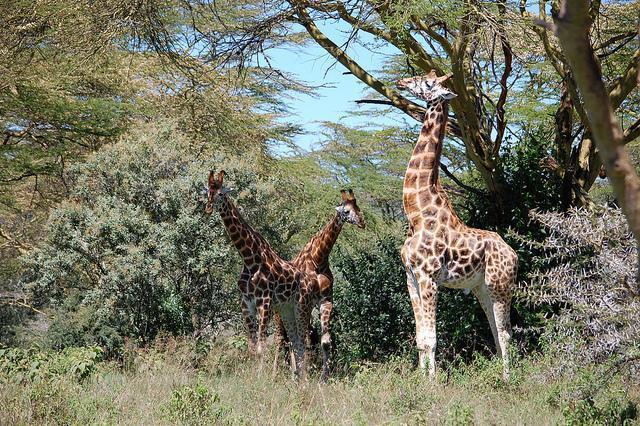How many giraffes are there?
Give a very brief answer. 3. How many giraffes can be seen?
Give a very brief answer. 3. How many people are in dresses?
Give a very brief answer. 0. 